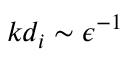Convert formula to latex. <formula><loc_0><loc_0><loc_500><loc_500>k d _ { i } \sim \epsilon ^ { - 1 }</formula> 